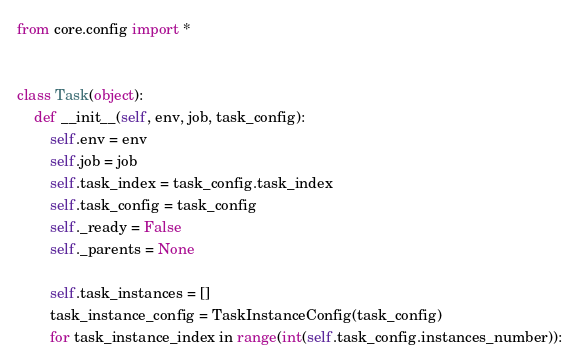<code> <loc_0><loc_0><loc_500><loc_500><_Python_>from core.config import *


class Task(object):
    def __init__(self, env, job, task_config):
        self.env = env
        self.job = job
        self.task_index = task_config.task_index
        self.task_config = task_config
        self._ready = False
        self._parents = None

        self.task_instances = []
        task_instance_config = TaskInstanceConfig(task_config)
        for task_instance_index in range(int(self.task_config.instances_number)):</code> 